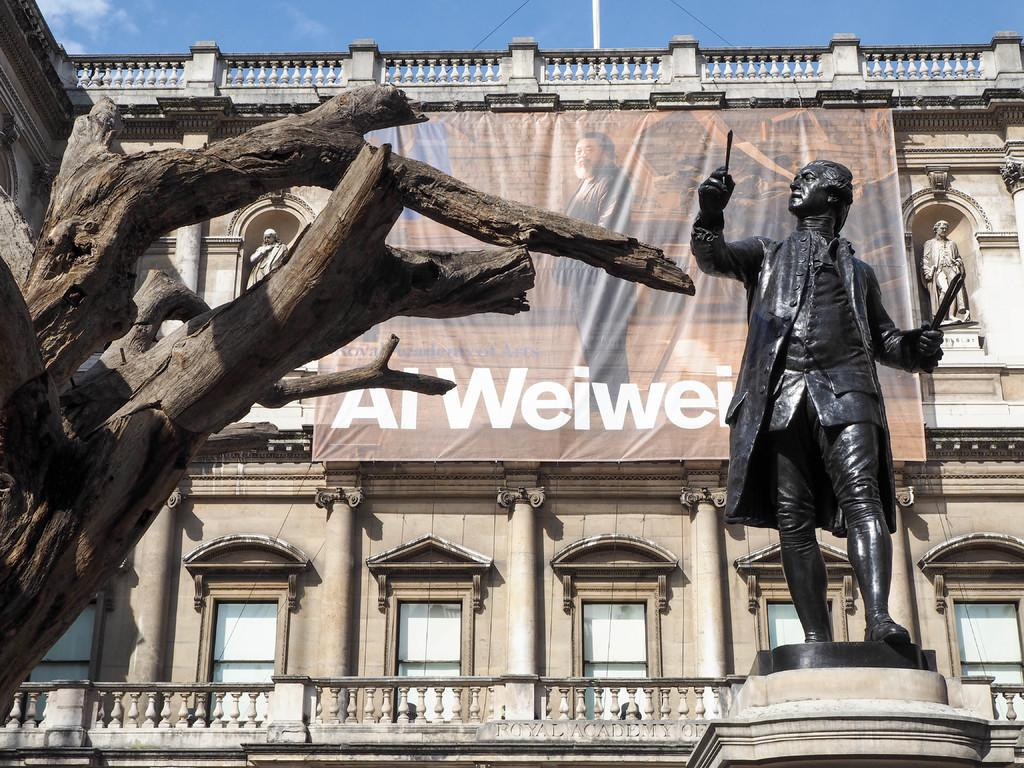Provide a one-sentence caption for the provided image. Al Weiwei has very bold white font on the front red brock fascia, which helps add contrast to the surroundings. 